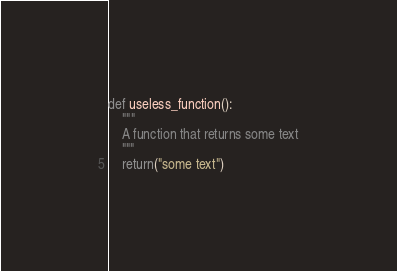<code> <loc_0><loc_0><loc_500><loc_500><_Python_>def useless_function():
    """ 
    A function that returns some text
    """
    return("some text")
</code> 